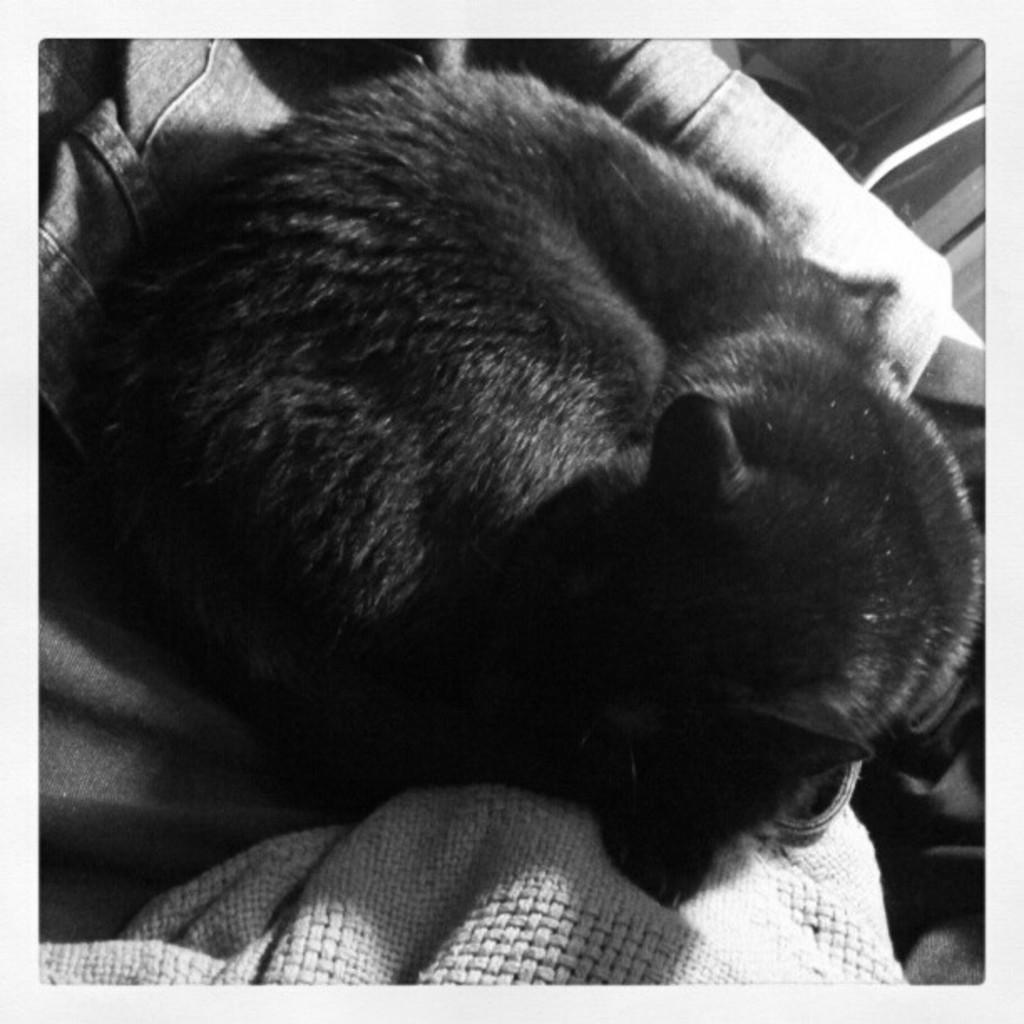What type of animal is in the image? There is a black color cat in the image. What is the cat sitting on? The cat is sitting on a white color cloth. How many grapes are hanging from the cat's tail in the image? There are no grapes present in the image, and the cat's tail is not mentioned in the provided facts. 